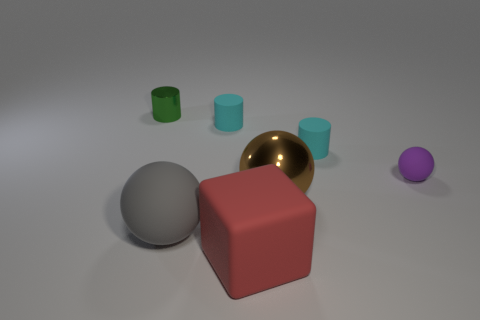Is the material of the big object on the left side of the red block the same as the tiny green object?
Your answer should be compact. No. Are there fewer purple matte spheres in front of the cube than small objects that are on the right side of the big gray rubber ball?
Keep it short and to the point. Yes. Are there any other things that have the same shape as the red matte thing?
Offer a terse response. No. There is a big ball behind the rubber ball left of the small purple matte object; what number of large brown metal things are right of it?
Ensure brevity in your answer.  0. How many objects are in front of the purple rubber thing?
Offer a terse response. 3. What number of objects have the same material as the red block?
Keep it short and to the point. 4. There is a ball that is the same material as the tiny green thing; what color is it?
Offer a very short reply. Brown. There is a big thing that is on the right side of the thing that is in front of the matte ball that is on the left side of the small rubber ball; what is its material?
Your answer should be very brief. Metal. Does the cylinder on the left side of the gray rubber ball have the same size as the small purple rubber sphere?
Your response must be concise. Yes. How many big objects are red cubes or cyan cylinders?
Your response must be concise. 1. 